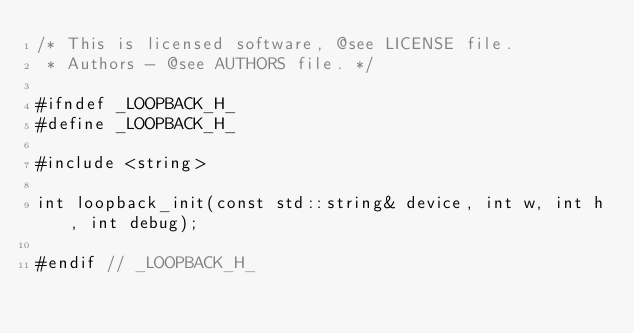<code> <loc_0><loc_0><loc_500><loc_500><_C_>/* This is licensed software, @see LICENSE file.
 * Authors - @see AUTHORS file. */

#ifndef _LOOPBACK_H_
#define _LOOPBACK_H_

#include <string>

int loopback_init(const std::string& device, int w, int h, int debug);

#endif // _LOOPBACK_H_
</code> 